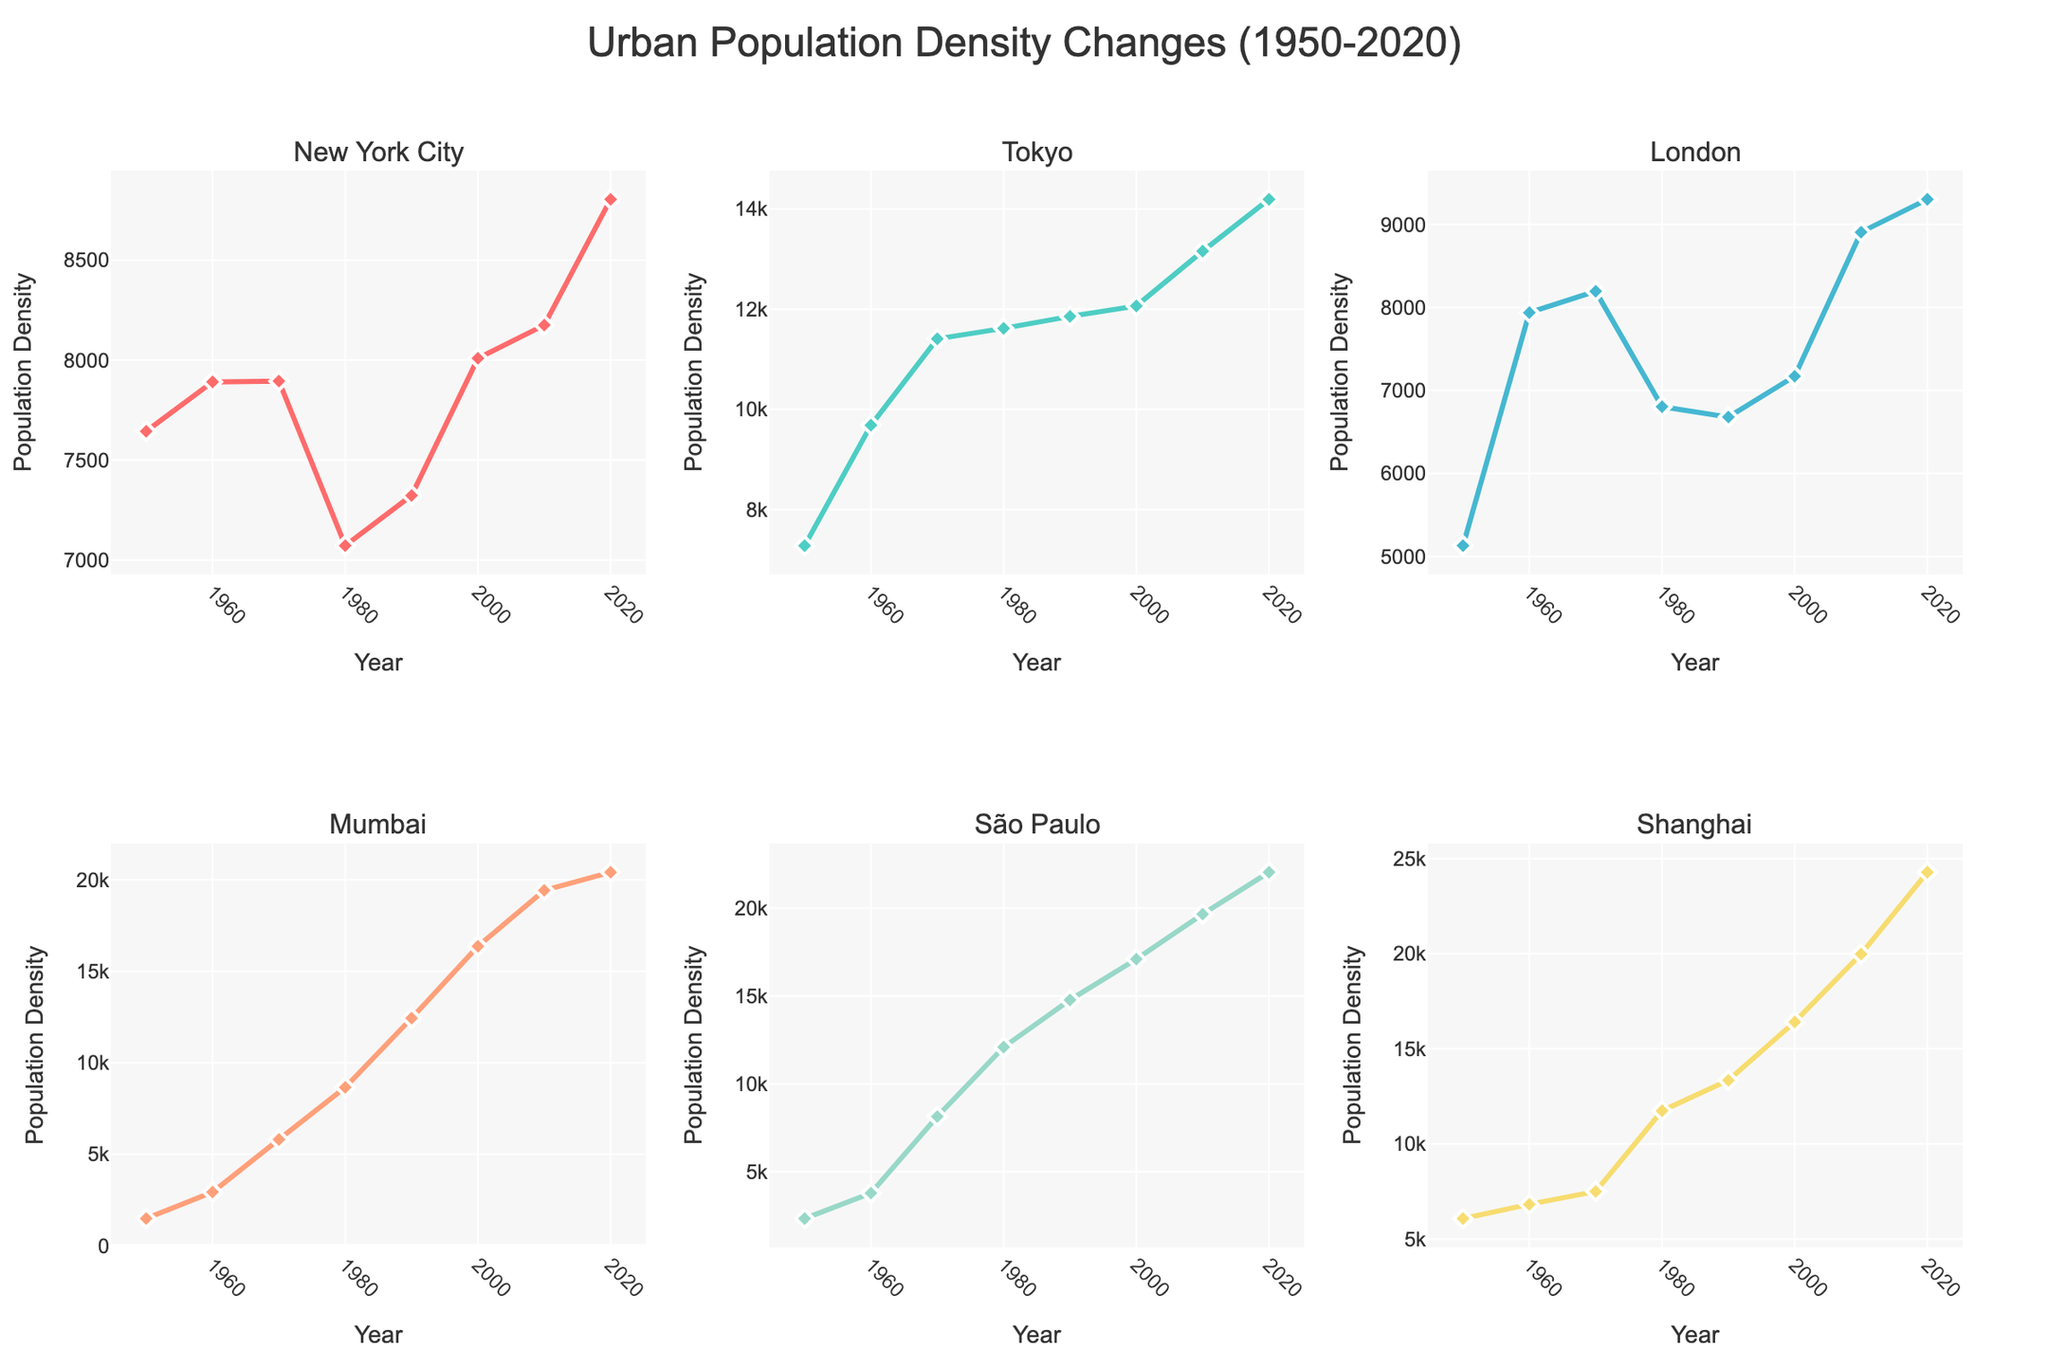How many positions are plotted in the "Offensive Players" subplot? To find the number of positions, look at the legend or the different marker colors/types in the "Offensive Players" subplot. Count the unique positions represented.
Answer: 4 Who is the fastest wide receiver in terms of the 40-yard dash time? Check the "Wide Receiver" points in the plot. The fastest player will have the lowest 40-yard dash time on the y-axis.
Answer: Tyreek Hill Between quarterbacks and running backs, which position generally has heavier players? Compare the general location of the "Quarterback" and "Running Back" points along the x-axis (weight). The position with points generally further to the right is heavier.
Answer: Quarterback What is the relationship between weight and speed for linebackers in the "Defensive Players" subplot? Look at the plot points for "Linebacker" in the "Defensive Players" subplot. Notice the trend if heavier linebackers tend to be slower. Generally, as weight increases, speed decreases, signifying slower 40-yard dash times.
Answer: As weight increases, speed decreases Which group has the heaviest player overall? Identify the position of the player with the highest weight by looking at the points furthest to the right in all subplots.
Answer: Offensive Tackle How does Stephon Gilmore's speed compare to Jalen Ramsey's? Find Stephon Gilmore and Jalen Ramsey in the "Defensive Players" subplot and compare their y-axis values. The player with a lower y-axis value is faster.
Answer: They have the same speed Who has the fastest 40-yard dash time among all the players in the "Special Positions" subplot? Look for the player with the lowest value on the y-axis in the "Special Positions" subplot.
Answer: Tyreek Hill Which position has the widest range of weights in the "Offensive Players" subplot? Observe the spread of weights (x-axis) for each position in the "Offensive Players" subplot. The position with the largest spread from the lowest to highest weight has the widest range.
Answer: Tight End Which group shows the most overlap in weight and speed in the "Linemen" subplot? Look at the points in the "Linemen" subplot. Compare the overlap of weights and speeds between "Offensive Tackle" and "Defensive End".
Answer: Some overlap Which tight end is the heaviest? In the "Offensive Players" subplot, identify the "Tight End" player with the highest weight (furthest right on the x-axis).
Answer: Rob Gronkowski 